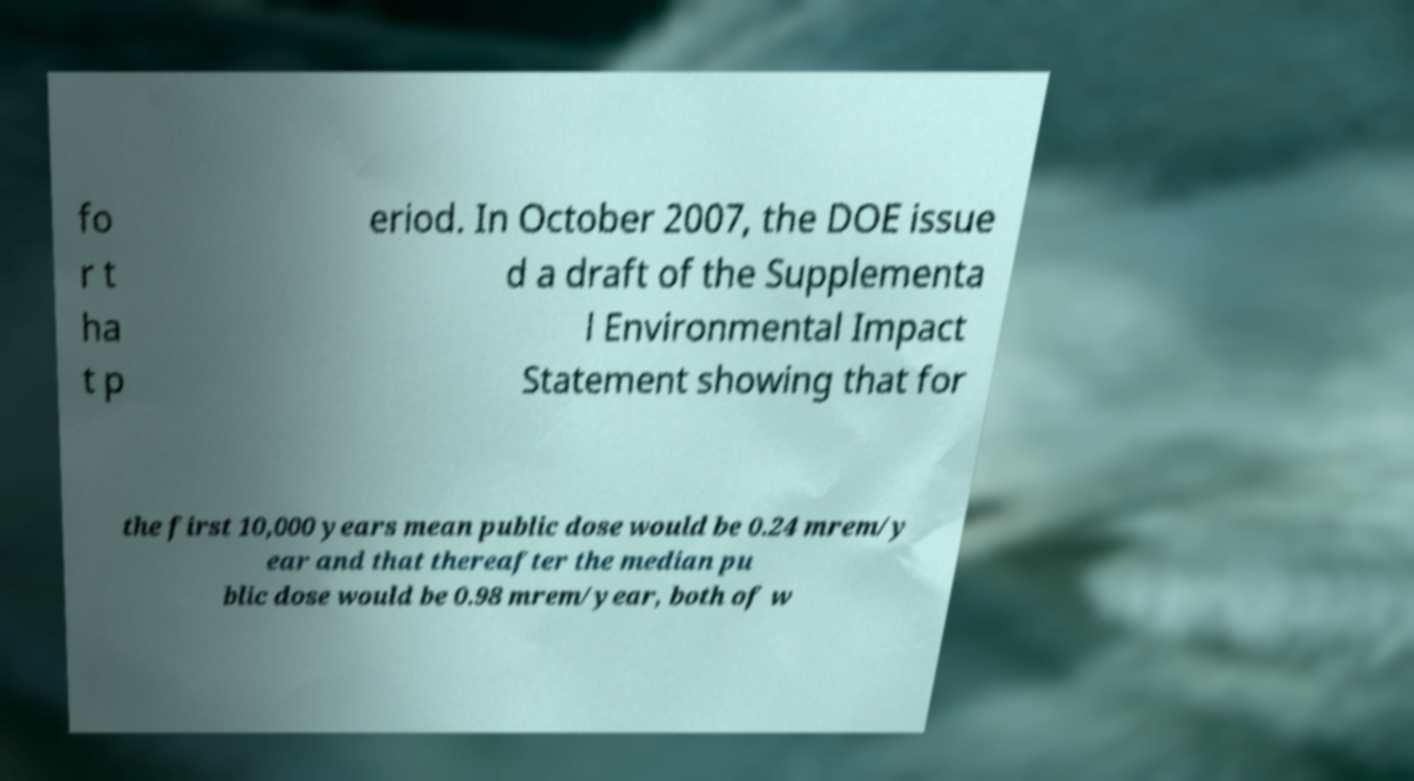Can you accurately transcribe the text from the provided image for me? fo r t ha t p eriod. In October 2007, the DOE issue d a draft of the Supplementa l Environmental Impact Statement showing that for the first 10,000 years mean public dose would be 0.24 mrem/y ear and that thereafter the median pu blic dose would be 0.98 mrem/year, both of w 